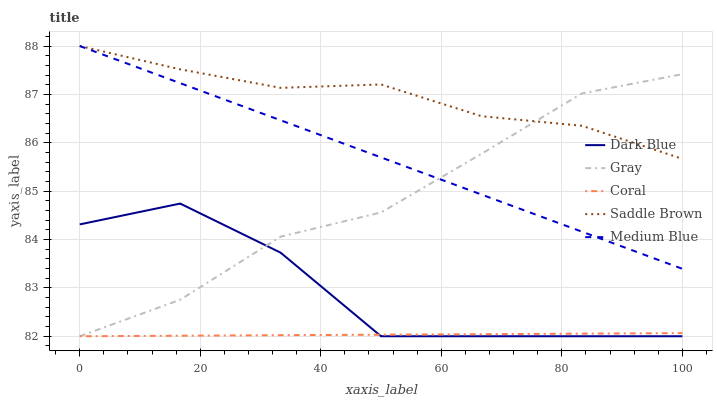Does Medium Blue have the minimum area under the curve?
Answer yes or no. No. Does Medium Blue have the maximum area under the curve?
Answer yes or no. No. Is Coral the smoothest?
Answer yes or no. No. Is Coral the roughest?
Answer yes or no. No. Does Medium Blue have the lowest value?
Answer yes or no. No. Does Coral have the highest value?
Answer yes or no. No. Is Coral less than Medium Blue?
Answer yes or no. Yes. Is Saddle Brown greater than Coral?
Answer yes or no. Yes. Does Coral intersect Medium Blue?
Answer yes or no. No. 